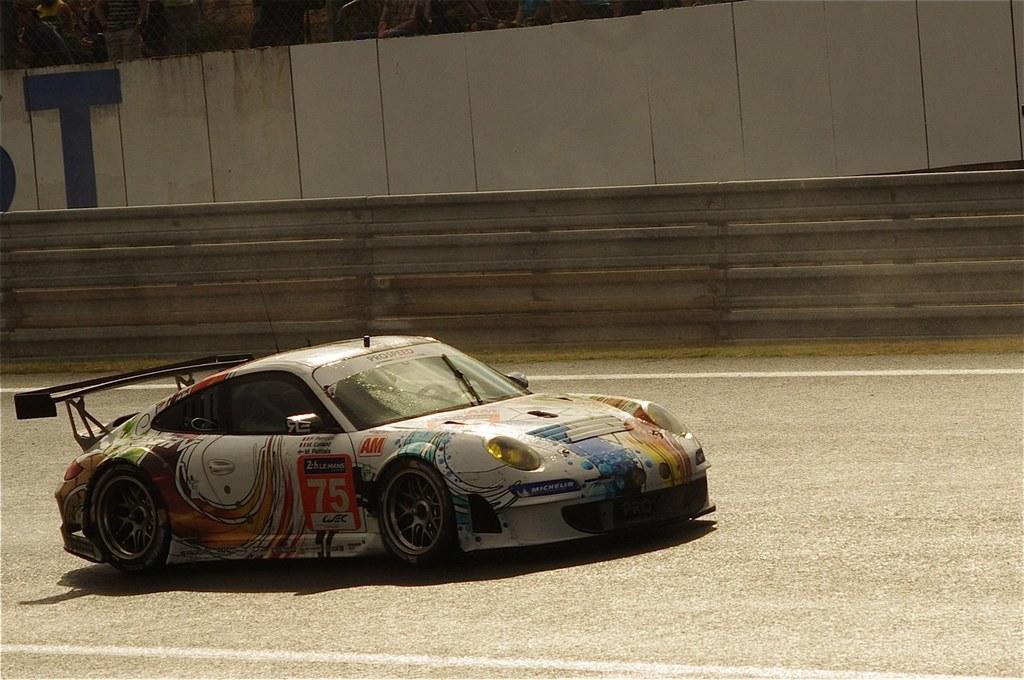Please provide a concise description of this image. In the foreground of the picture there is a car and there is road. In the background there is wall. At the top there are audience. 